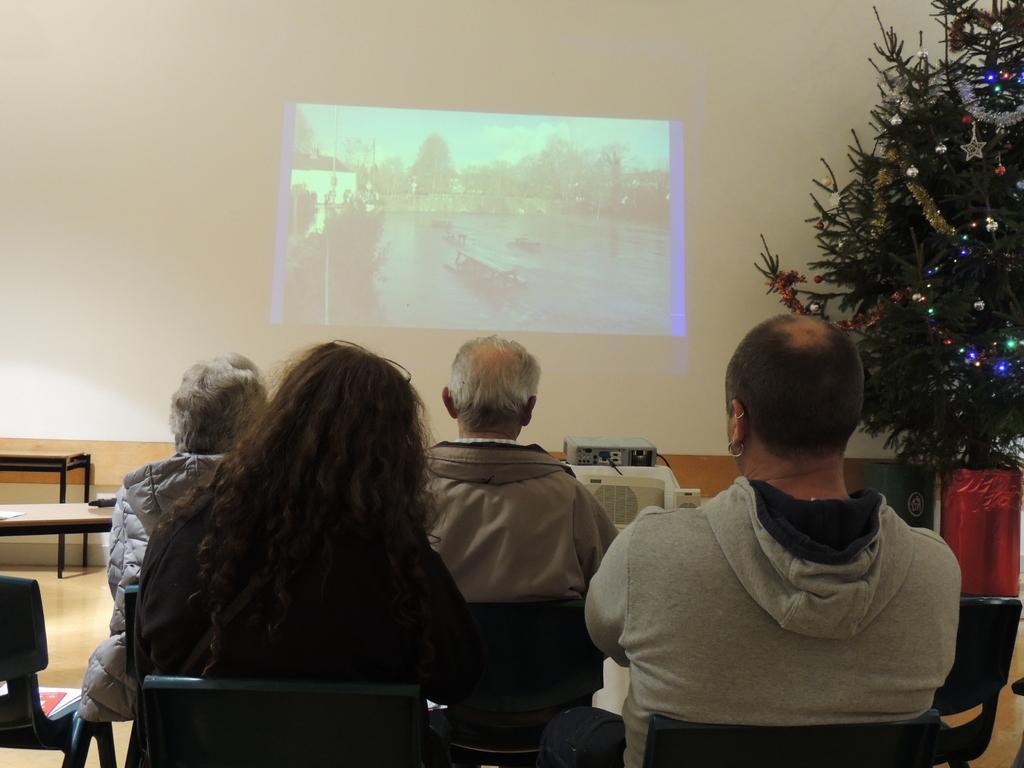In one or two sentences, can you explain what this image depicts? This picture is clicked inside the room. Here, we see four people sitting on the chairs and watching the movie, which is projected on the wall. In front of them, we see a projector. In the background, we see a white wall on which movie is projected. On the right side of the picture, we see a Christmas tree. 